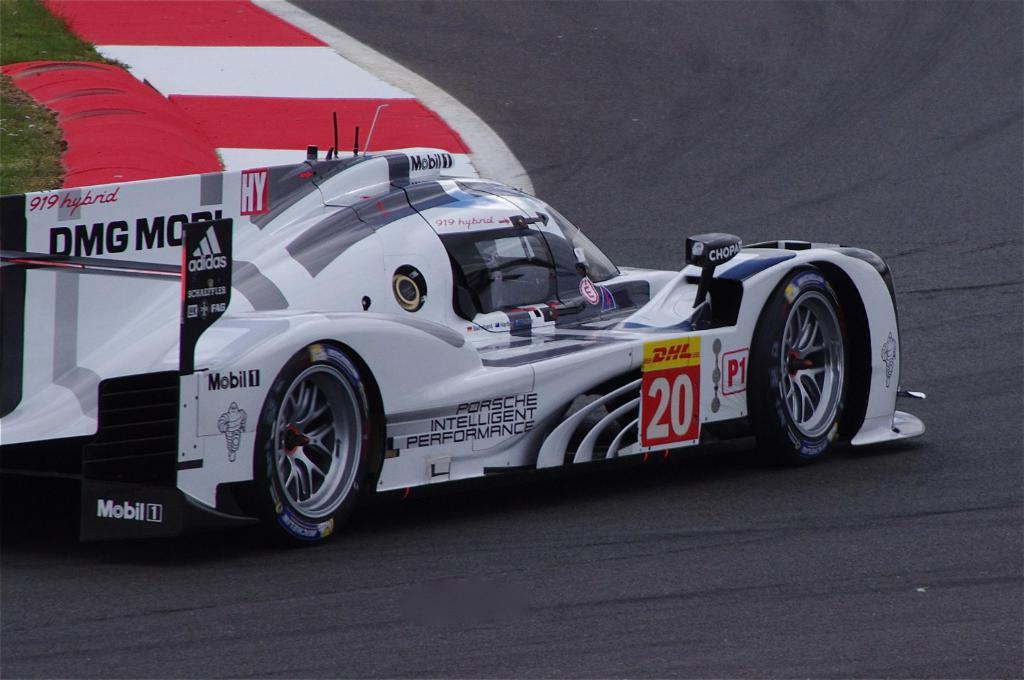What is the main subject of the image? The main subject of the image is a racing car. Where is the car located in the image? The car is on the road in the image. What can be seen on the car? There is text on the car. What type of vegetation is on the left side of the image? There is grass on the left side of the image. What other feature is present on the left side of the image? There is a footpath on the left side of the image. What type of linen is draped over the yard in the image? There is no yard or linen present in the image; it features a racing car on the road with grass and a footpath on the left side. 